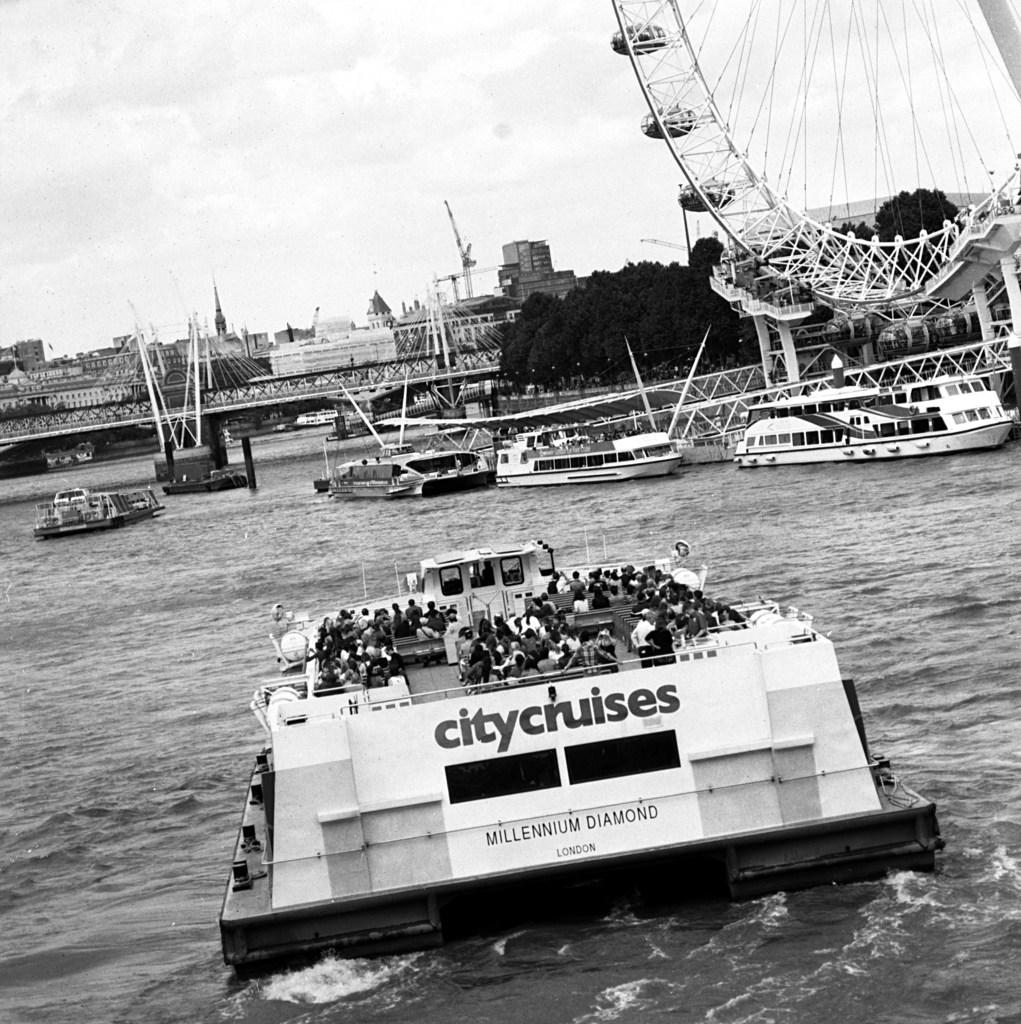<image>
Offer a succinct explanation of the picture presented. A black and white photo of a city cruise tour boat from London. 